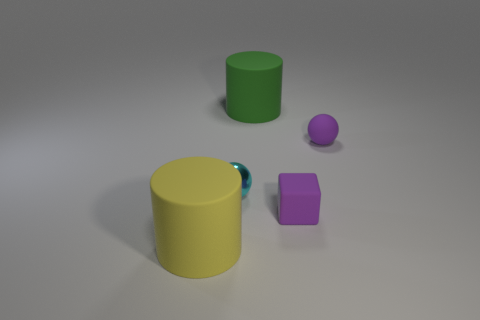Do the cyan thing and the large yellow cylinder have the same material? The cyan object and the large yellow cylinder appear to have different levels of shininess, which suggests that they might be made from different materials. The yellow cylinder has a more matte finish indicating it could be made from plastic or painted metal, while the cyan object has a glossier look, which is often characteristic of materials like polished metal or ceramic. 